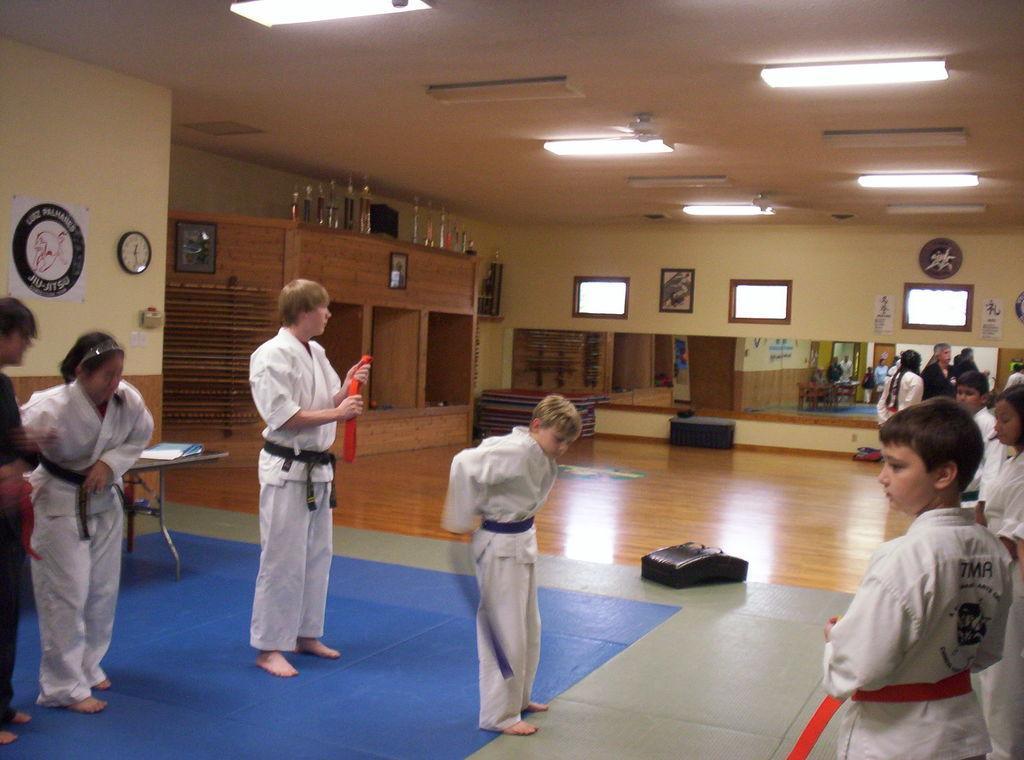Could you give a brief overview of what you see in this image? This picture describes about group of people, beside to the we can see a file on the table and few bottles on the cupboards, and also we can see a wall clock and few paintings on the wall, on top of them we can find few lights. 